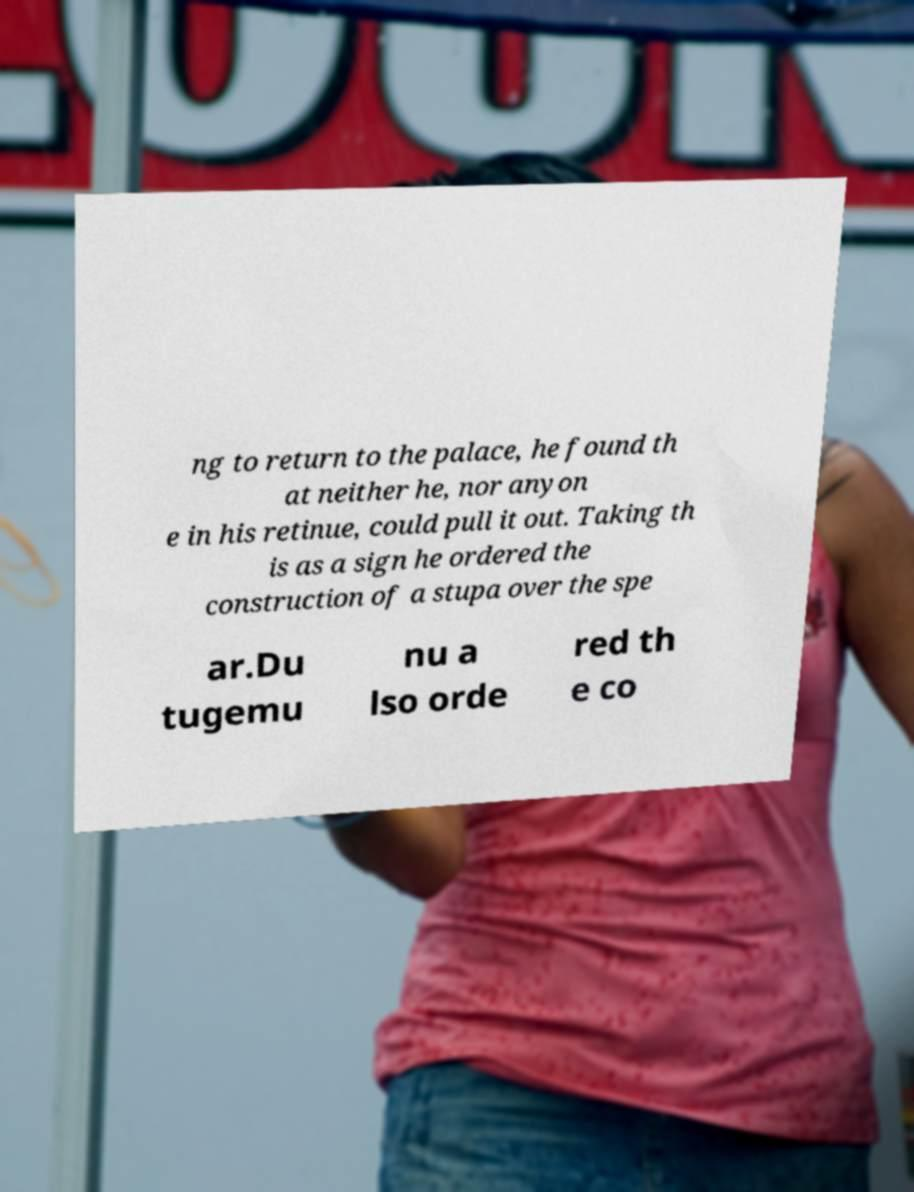Please identify and transcribe the text found in this image. ng to return to the palace, he found th at neither he, nor anyon e in his retinue, could pull it out. Taking th is as a sign he ordered the construction of a stupa over the spe ar.Du tugemu nu a lso orde red th e co 